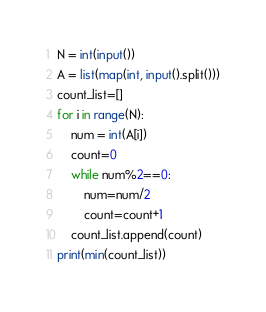Convert code to text. <code><loc_0><loc_0><loc_500><loc_500><_Python_>N = int(input())
A = list(map(int, input().split()))
count_list=[]
for i in range(N):
	num = int(A[i])
	count=0
	while num%2==0:
		num=num/2
		count=count+1
	count_list.append(count)
print(min(count_list))</code> 